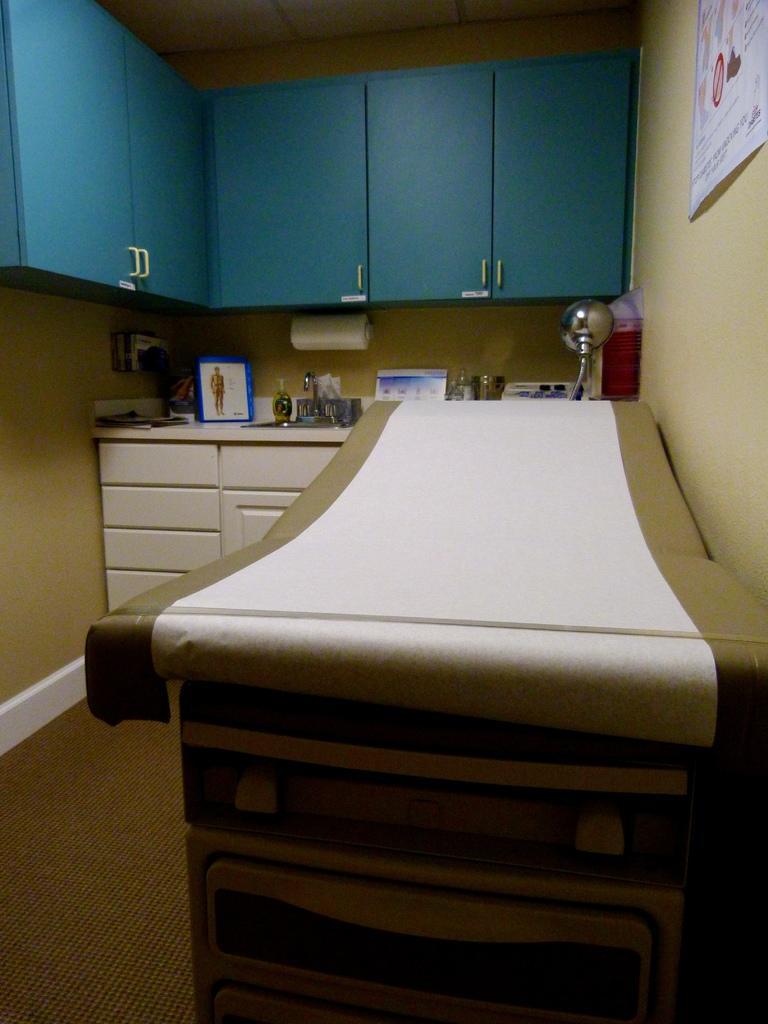Describe this image in one or two sentences. There are cupboards and this is a poster. Here we can see a bed, frames, and a tissue roll. This is floor and there is a wall. 